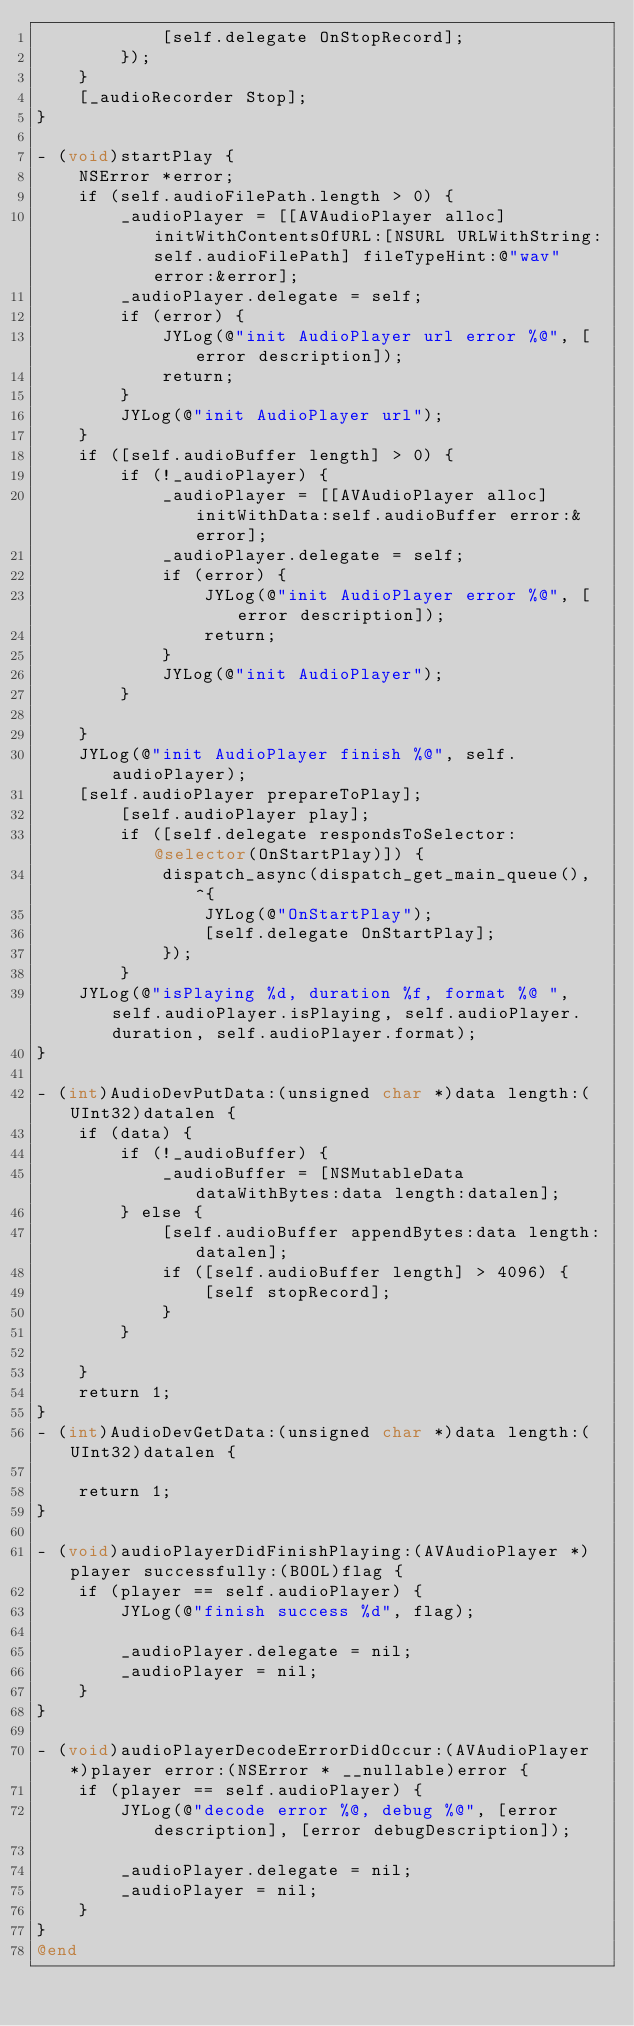<code> <loc_0><loc_0><loc_500><loc_500><_ObjectiveC_>            [self.delegate OnStopRecord];
        });
    }
    [_audioRecorder Stop];
}

- (void)startPlay {
    NSError *error;
    if (self.audioFilePath.length > 0) {
        _audioPlayer = [[AVAudioPlayer alloc] initWithContentsOfURL:[NSURL URLWithString:self.audioFilePath] fileTypeHint:@"wav" error:&error];
        _audioPlayer.delegate = self;
        if (error) {
            JYLog(@"init AudioPlayer url error %@", [error description]);
            return;
        }
        JYLog(@"init AudioPlayer url");
    }
    if ([self.audioBuffer length] > 0) {
        if (!_audioPlayer) {
            _audioPlayer = [[AVAudioPlayer alloc] initWithData:self.audioBuffer error:&error];
            _audioPlayer.delegate = self;
            if (error) {
                JYLog(@"init AudioPlayer error %@", [error description]);
                return;
            }
            JYLog(@"init AudioPlayer");
        }
        
    }
    JYLog(@"init AudioPlayer finish %@", self.audioPlayer);
    [self.audioPlayer prepareToPlay];
        [self.audioPlayer play];
        if ([self.delegate respondsToSelector:@selector(OnStartPlay)]) {
            dispatch_async(dispatch_get_main_queue(), ^{
                JYLog(@"OnStartPlay");
                [self.delegate OnStartPlay];
            });
        }
    JYLog(@"isPlaying %d, duration %f, format %@ ", self.audioPlayer.isPlaying, self.audioPlayer.duration, self.audioPlayer.format);
}

- (int)AudioDevPutData:(unsigned char *)data length:(UInt32)datalen {
    if (data) {
        if (!_audioBuffer) {
            _audioBuffer = [NSMutableData dataWithBytes:data length:datalen];
        } else {
            [self.audioBuffer appendBytes:data length:datalen];
            if ([self.audioBuffer length] > 4096) {
                [self stopRecord];
            }
        }
        
    }
    return 1;
}
- (int)AudioDevGetData:(unsigned char *)data length:(UInt32)datalen {
    
    return 1;
}

- (void)audioPlayerDidFinishPlaying:(AVAudioPlayer *)player successfully:(BOOL)flag {
    if (player == self.audioPlayer) {
        JYLog(@"finish success %d", flag);
        
        _audioPlayer.delegate = nil;
        _audioPlayer = nil;
    }
}

- (void)audioPlayerDecodeErrorDidOccur:(AVAudioPlayer *)player error:(NSError * __nullable)error {
    if (player == self.audioPlayer) {
        JYLog(@"decode error %@, debug %@", [error description], [error debugDescription]);
        
        _audioPlayer.delegate = nil;
        _audioPlayer = nil;
    }
}
@end
</code> 